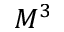Convert formula to latex. <formula><loc_0><loc_0><loc_500><loc_500>M ^ { 3 }</formula> 